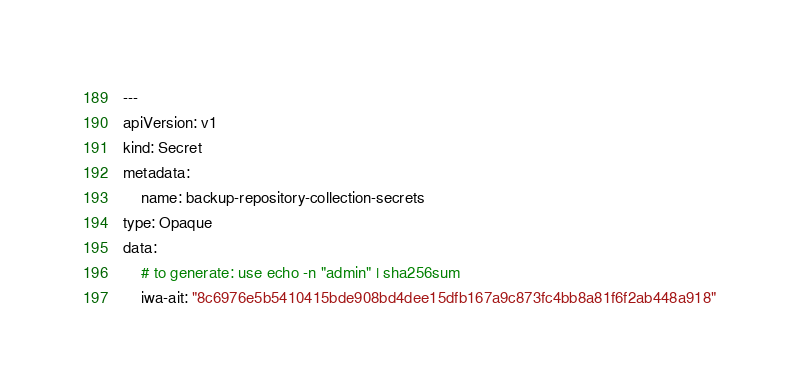Convert code to text. <code><loc_0><loc_0><loc_500><loc_500><_YAML_>---
apiVersion: v1
kind: Secret
metadata:
    name: backup-repository-collection-secrets
type: Opaque
data:
    # to generate: use echo -n "admin" | sha256sum
    iwa-ait: "8c6976e5b5410415bde908bd4dee15dfb167a9c873fc4bb8a81f6f2ab448a918"
</code> 